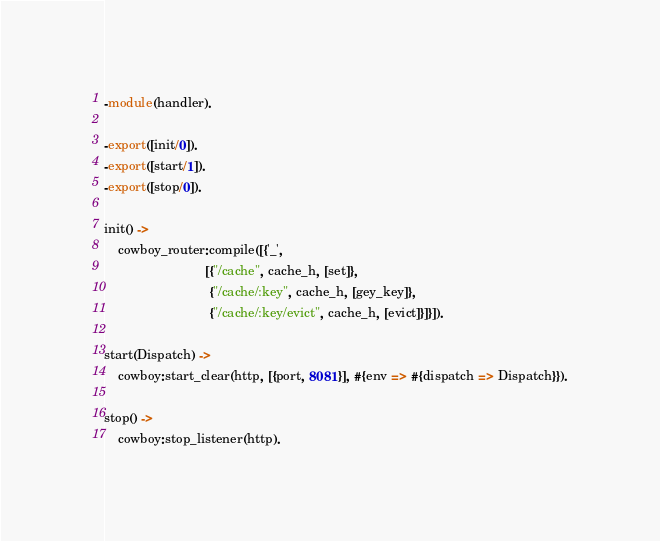<code> <loc_0><loc_0><loc_500><loc_500><_Erlang_>-module(handler).

-export([init/0]).
-export([start/1]).
-export([stop/0]).

init() ->
    cowboy_router:compile([{'_',
                            [{"/cache", cache_h, [set]},
                             {"/cache/:key", cache_h, [gey_key]},
                             {"/cache/:key/evict", cache_h, [evict]}]}]).

start(Dispatch) ->
    cowboy:start_clear(http, [{port, 8081}], #{env => #{dispatch => Dispatch}}).

stop() ->
    cowboy:stop_listener(http).
</code> 